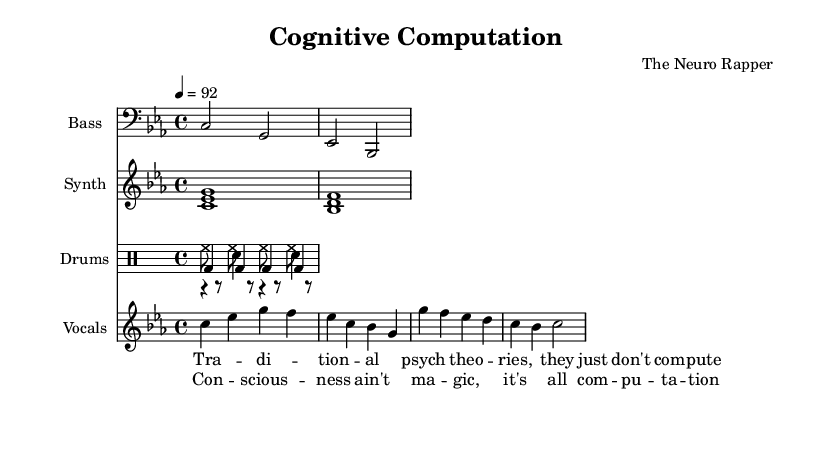What is the key signature of this music? The key signature is C minor, indicated by the three flats (B♭, E♭, and A♭) at the beginning of the staff.
Answer: C minor What is the time signature of the piece? The time signature is four-four, shown at the beginning of the sheet music with the "4/4" notation, meaning there are four beats in a measure and the quarter note receives one beat.
Answer: 4/4 What is the tempo marking for this piece? The tempo marking is 92 beats per minute, indicated at the beginning as "4 = 92," which specifies the speed of the piece.
Answer: 92 Which instrument has the bass line in this score? The instrument with the bass line is named "Bass," shown in the staff labeled with that name, which plays a lower pitch than other instruments.
Answer: Bass How many different drum voices are used? There are three distinct drum voices used in this score: kick drum, snare drum, and hi-hat, which are indicated in separate staff sections labeled accordingly.
Answer: Three What is the main lyrical theme of the song? The main lyrical theme critiques traditional psychological theories, emphasized in the lyrics that advocate for a computational understanding of consciousness, as illustrated in both the verse and chorus.
Answer: Computational theory 